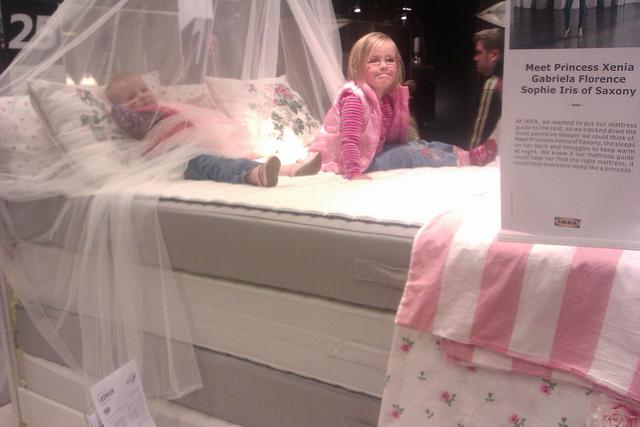Why is there a sign on the bed?

Choices:
A) for fun
B) as joke
C) as decoration
D) to sell to sell 